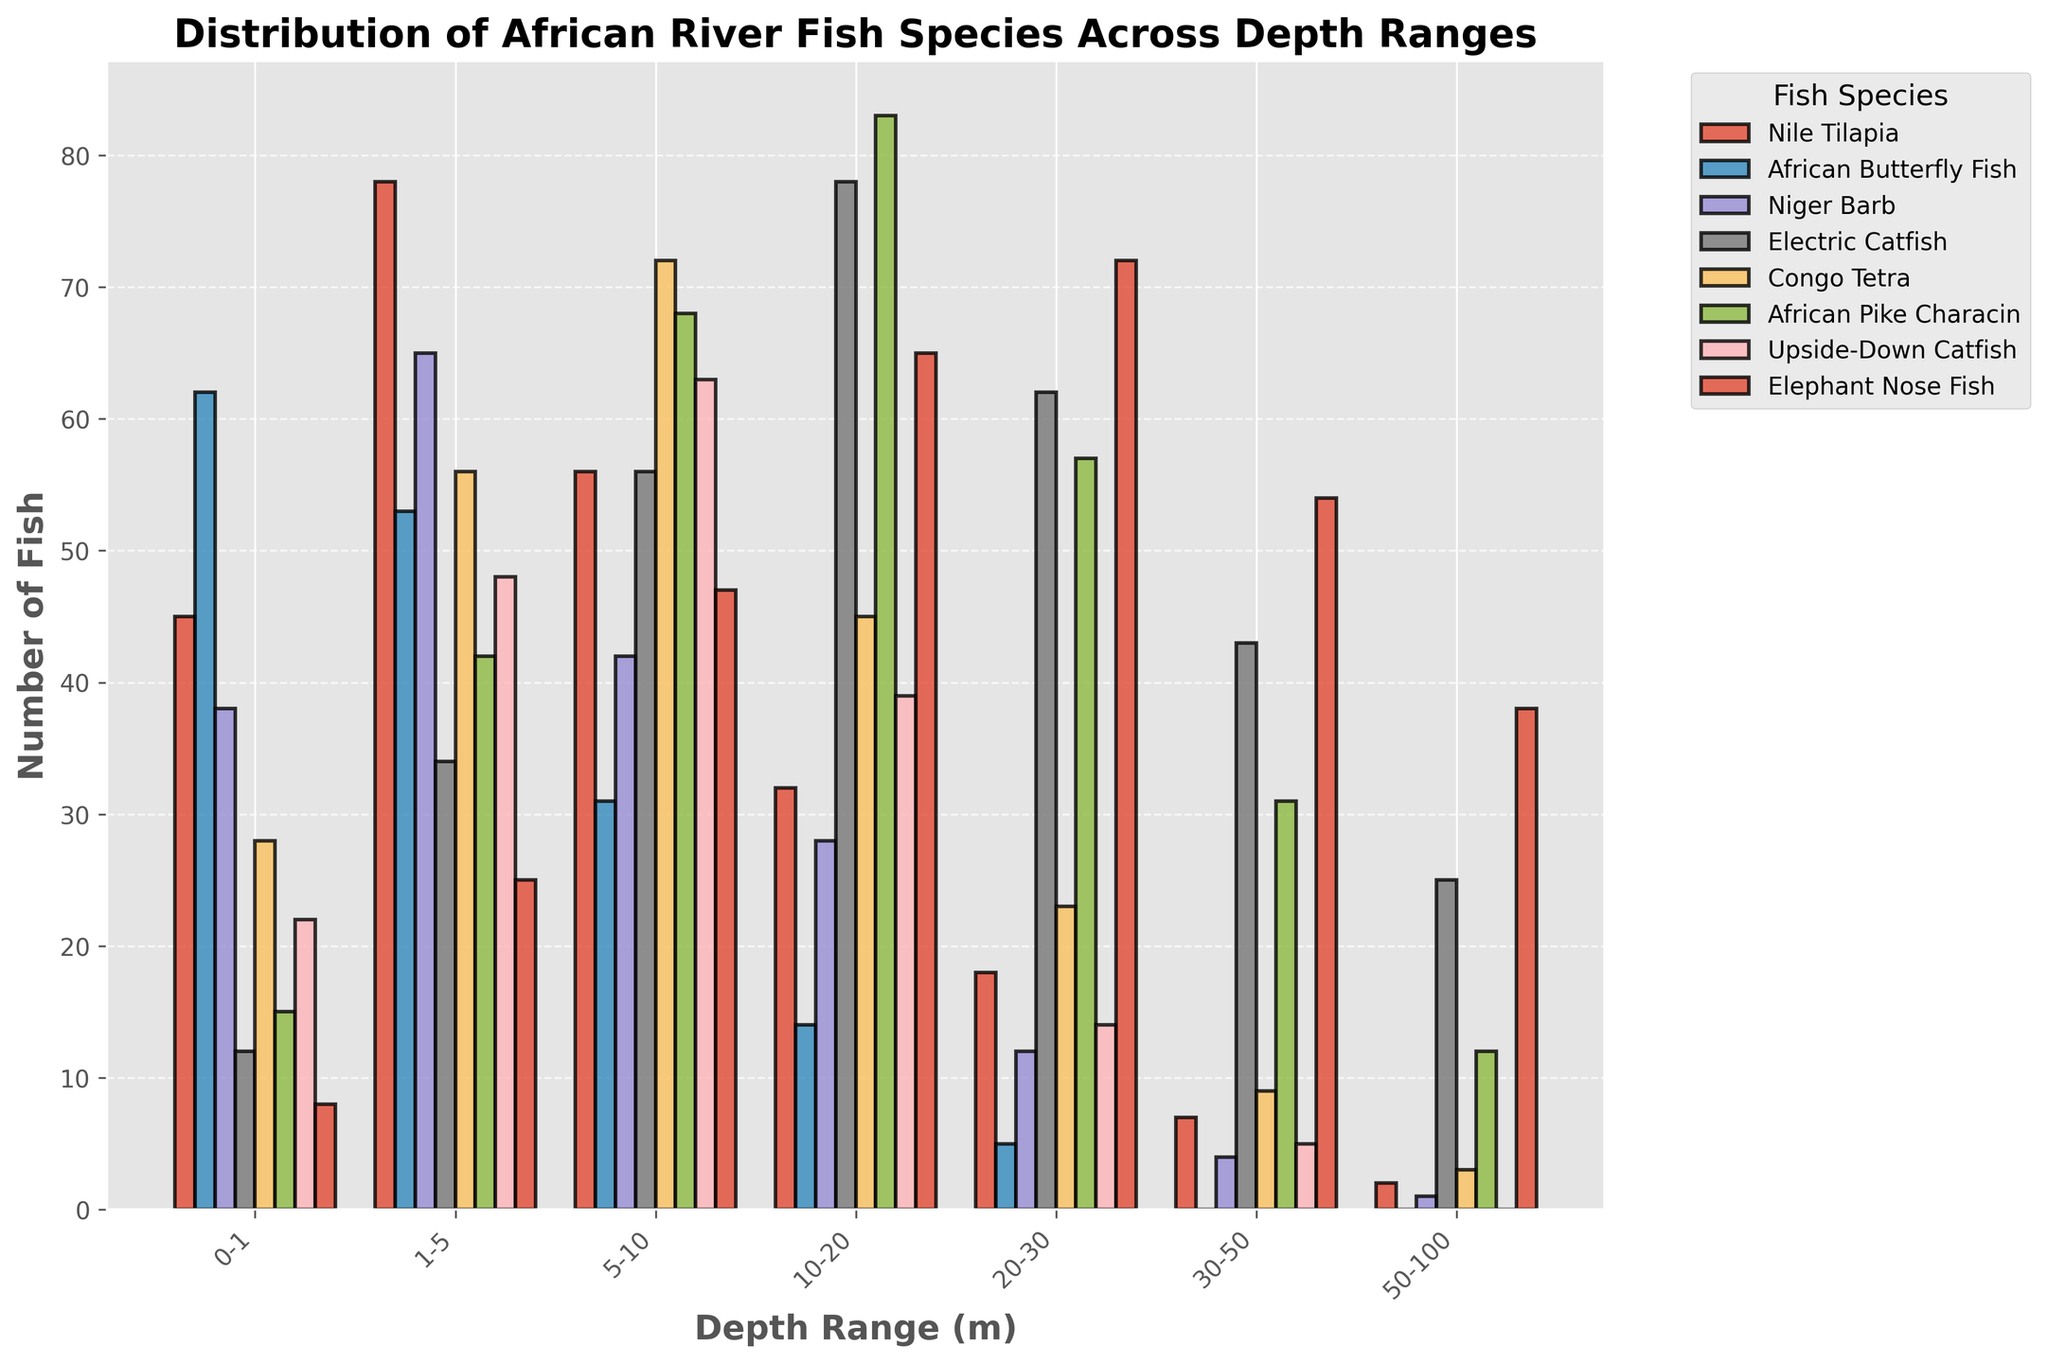What depth range has the highest number of Electric Catfish? Look at the figure to find the tallest bar for Electric Catfish, which is visually distinguishable based on the consistent color for Electric Catfish across all depth ranges. Identify the depth range on the x-axis below that bar.
Answer: 10-20 m Which species dominates the 1-5 m depth range? Find the tallest bar within the 1-5 m category on the x-axis. Compare the heights of bars representing different species within this depth range.
Answer: Nile Tilapia What is the sum of Congo Tetra in the 10-20 m and 20-30 m depth ranges? Identify and read the bars for Congo Tetra in the 10-20 m and 20-30 m ranges. Add the values shown directly above these bars.
Answer: 45 + 23 = 68 Which fish species are entirely absent in the 50-100 m depth range? Determine which bars are missing (not visible) within the 50-100 m depth range by scanning vertically. Identify the fish species corresponding to those positions from the legend.
Answer: African Butterfly Fish, Niger Barb, Upside-Down Catfish What is the average number of Niger Barb in the 5-10 m and 30-50 m depth ranges? Find and sum the heights of the bars for Niger Barb in the 5-10 m and 30-50 m depth ranges. Divide the total by 2 to get the average value.
Answer: (42 + 4) / 2 = 23 Which species shows the most significant decrease from the 0-1 m to the 1-5 m depth range? Examine each species' bar heights in the 0-1 m and 1-5 m ranges. Calculate the difference for each species, and find the one with the largest negative value.
Answer: African Butterfly Fish Is the value for Elephant Nose Fish greater in the 30-50 m range than in the 50-100 m range? Compare the heights of the bars for Elephant Nose Fish in the 30-50 m and 50-100 m ranges to determine which is taller.
Answer: Yes What is the total number of fish species present in the 30-50 m depth range? Add up the heights of all bars within the 30-50 m category for each species. The height represents the number of fish species in that range.
Answer: 7 + 0 + 4 + 43 + 9 + 31 + 5 + 54 = 153 Which fish species has more than 50 individuals in the 5-10 m depth range? Look at the figure to identify bars taller than the 50 mark in the 5-10 m range. Use the legend to determine the corresponding species.
Answer: Congo Tetra, African Pike Characin, Upside-Down Catfish, Elephant Nose Fish 